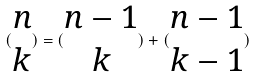Convert formula to latex. <formula><loc_0><loc_0><loc_500><loc_500>( \begin{matrix} n \\ k \end{matrix} ) = ( \begin{matrix} n - 1 \\ k \end{matrix} ) + ( \begin{matrix} n - 1 \\ k - 1 \end{matrix} )</formula> 